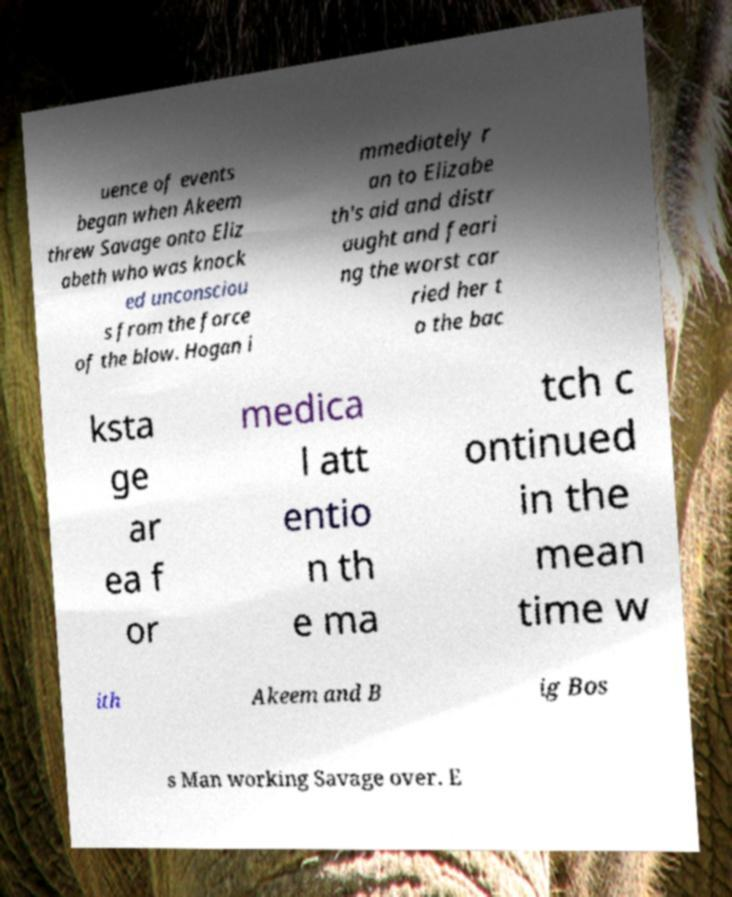There's text embedded in this image that I need extracted. Can you transcribe it verbatim? uence of events began when Akeem threw Savage onto Eliz abeth who was knock ed unconsciou s from the force of the blow. Hogan i mmediately r an to Elizabe th's aid and distr aught and feari ng the worst car ried her t o the bac ksta ge ar ea f or medica l att entio n th e ma tch c ontinued in the mean time w ith Akeem and B ig Bos s Man working Savage over. E 